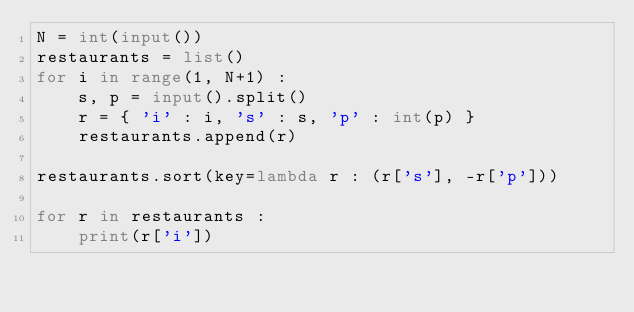Convert code to text. <code><loc_0><loc_0><loc_500><loc_500><_Python_>N = int(input())
restaurants = list()
for i in range(1, N+1) :
    s, p = input().split()
    r = { 'i' : i, 's' : s, 'p' : int(p) }
    restaurants.append(r)

restaurants.sort(key=lambda r : (r['s'], -r['p']))

for r in restaurants :
    print(r['i'])
</code> 